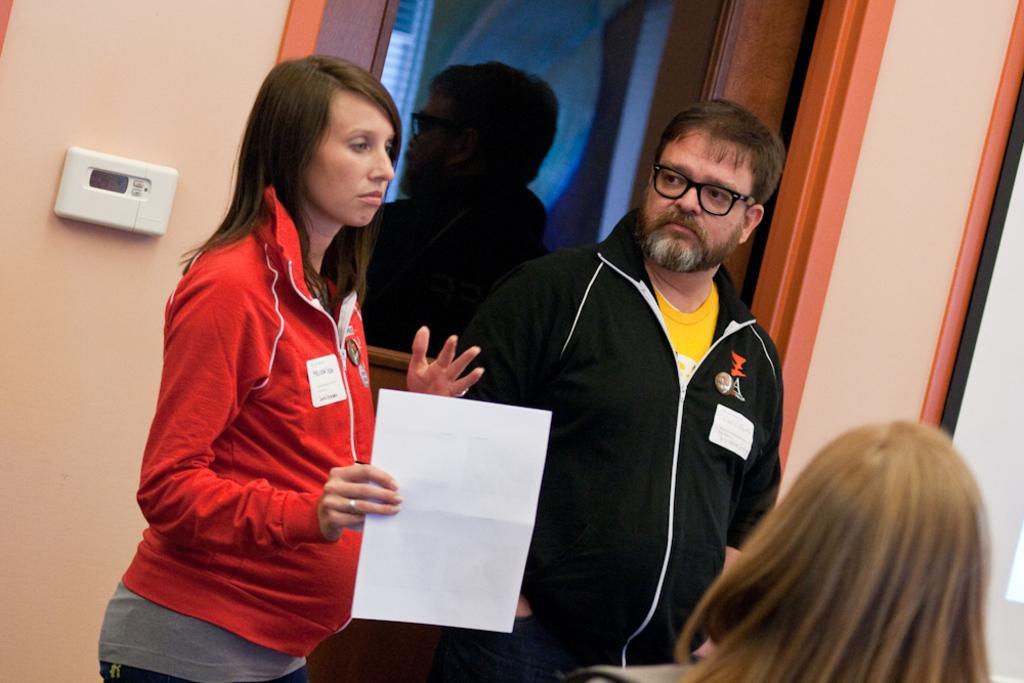In one or two sentences, can you explain what this image depicts? This picture seems to be clicked inside room. In the foreground we can see a person seems to be standing. On the left there is a woman holding a paper and standing on the ground and we can see a man standing on the ground. In the background we can see the wall and the reflection of a man in the glass object and we can see some objects in the background. 